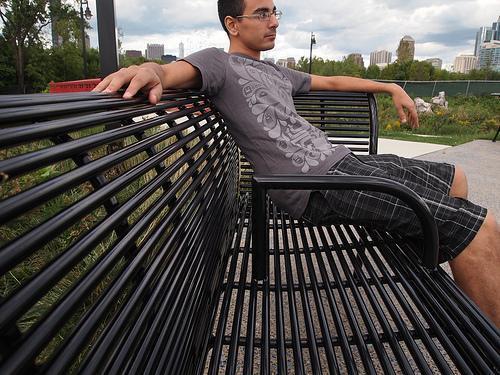How many people are in the picture?
Give a very brief answer. 1. 